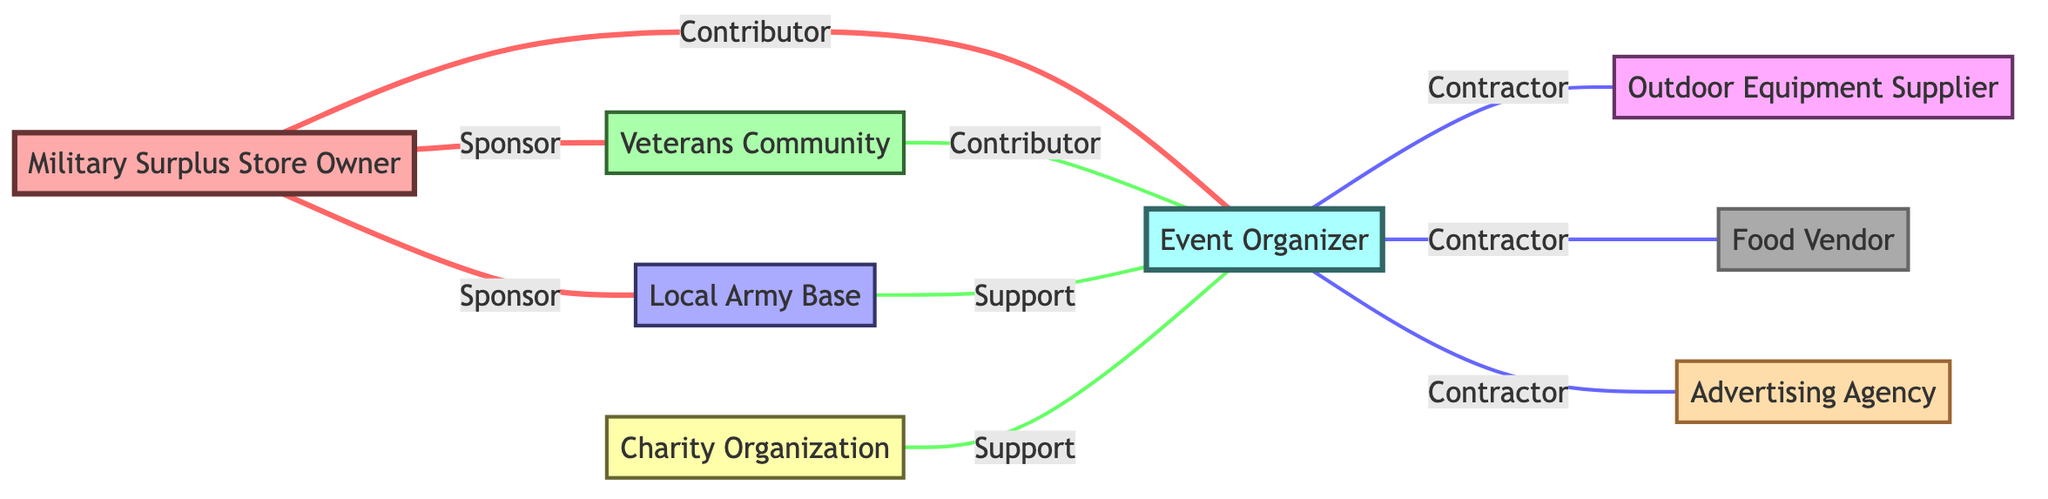What is the total number of nodes in the diagram? The diagram lists 8 different entities, which are the individuals or organizations, thus counting those gives us a total of 8 nodes.
Answer: 8 Which nodes are directly connected to the Military Surplus Store Owner? The Military Surplus Store Owner is directly connected to the Veterans Community, Local Army Base, and Event Organizer, making the count of directly connected nodes 3.
Answer: 3 What type of relationship exists between the Event Organizer and the Outdoor Equipment Supplier? The link between the Event Organizer and the Outdoor Equipment Supplier is labeled as "Contractor," indicating a working relationship.
Answer: Contractor Who contributes to the Event Organizer besides the Military Surplus Store Owner? The Veterans Community also contributes to the Event Organizer, making it the second contributor identified in the diagram.
Answer: Veterans Community How many types of relationships are there in total within the diagram? There are three different types of relationships evident from the connections in the diagram: Sponsor, Contributor, and Contractor, summing to a total of 3 distinct types.
Answer: 3 Which node has the most connections, and how many does it have? The Event Organizer has the most connections, totaling 5 different links to other nodes in the diagram.
Answer: Event Organizer, 5 Is there a direct support relationship between the Charity Organization and the Local Army Base? The Charity Organization does not have a direct support relationship with the Local Army Base, as there is no link connecting them in the diagram.
Answer: No Which organization supports the Event Organizer alongside the Local Army Base? The Charity Organization also supports the Event Organizer, making it the second supporter.
Answer: Charity Organization What is the type of link between the Food Vendor and the Event Organizer? The link between the Food Vendor and the Event Organizer is classified as "Contractor," which details their working arrangement.
Answer: Contractor 